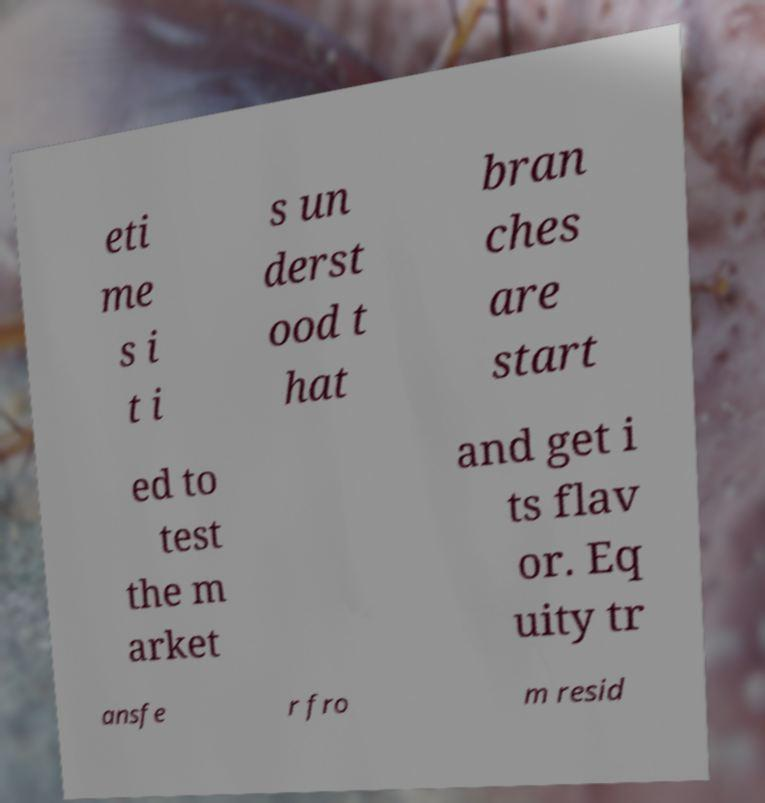For documentation purposes, I need the text within this image transcribed. Could you provide that? eti me s i t i s un derst ood t hat bran ches are start ed to test the m arket and get i ts flav or. Eq uity tr ansfe r fro m resid 